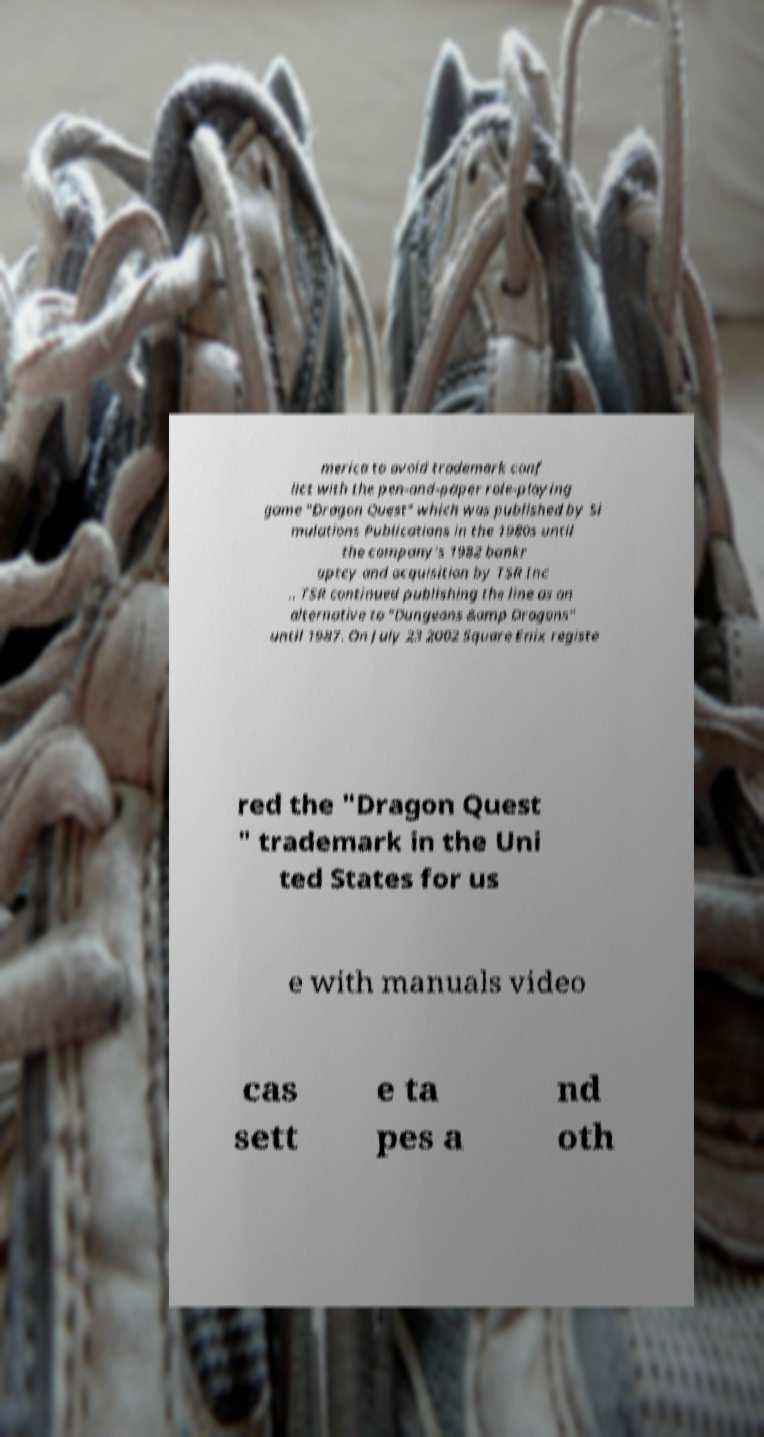Can you accurately transcribe the text from the provided image for me? merica to avoid trademark conf lict with the pen-and-paper role-playing game "Dragon Quest" which was published by Si mulations Publications in the 1980s until the company's 1982 bankr uptcy and acquisition by TSR Inc .. TSR continued publishing the line as an alternative to "Dungeons &amp Dragons" until 1987. On July 23 2002 Square Enix registe red the "Dragon Quest " trademark in the Uni ted States for us e with manuals video cas sett e ta pes a nd oth 